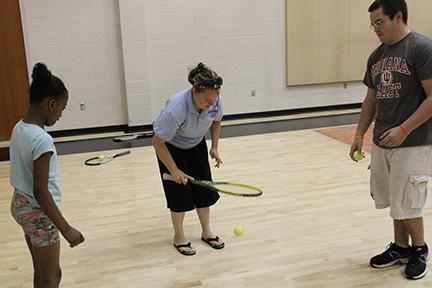What is the girl in the middle doing?
Answer briefly. Bouncing ball. Is the man in motion?
Quick response, please. No. What color is the wall?
Give a very brief answer. White. How many racquets in the picture?
Answer briefly. 3. 